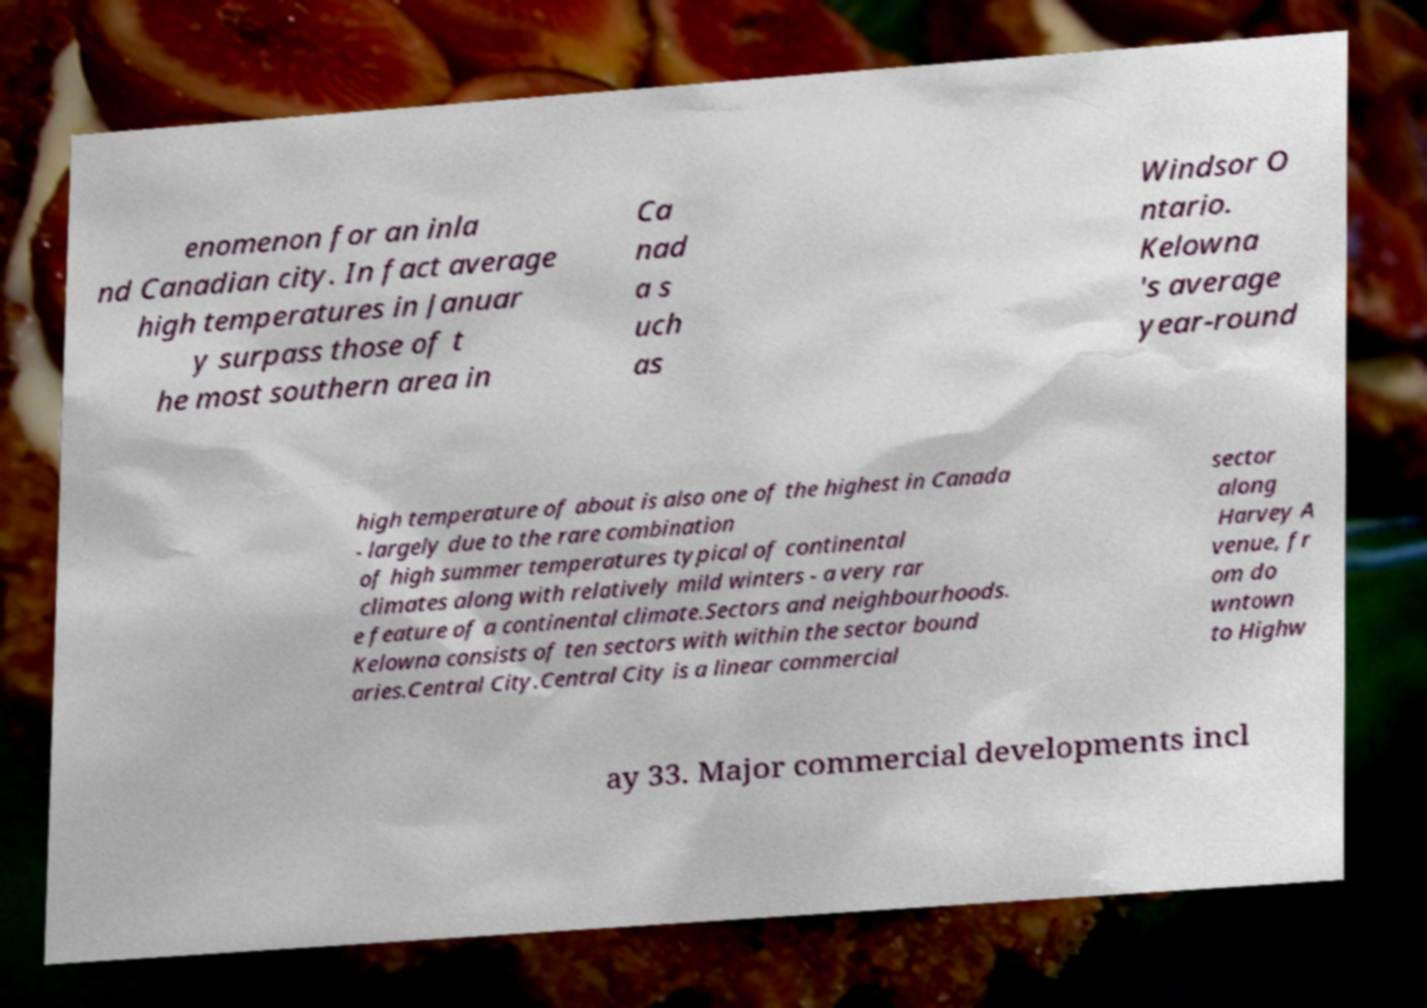Could you assist in decoding the text presented in this image and type it out clearly? enomenon for an inla nd Canadian city. In fact average high temperatures in Januar y surpass those of t he most southern area in Ca nad a s uch as Windsor O ntario. Kelowna 's average year-round high temperature of about is also one of the highest in Canada - largely due to the rare combination of high summer temperatures typical of continental climates along with relatively mild winters - a very rar e feature of a continental climate.Sectors and neighbourhoods. Kelowna consists of ten sectors with within the sector bound aries.Central City.Central City is a linear commercial sector along Harvey A venue, fr om do wntown to Highw ay 33. Major commercial developments incl 